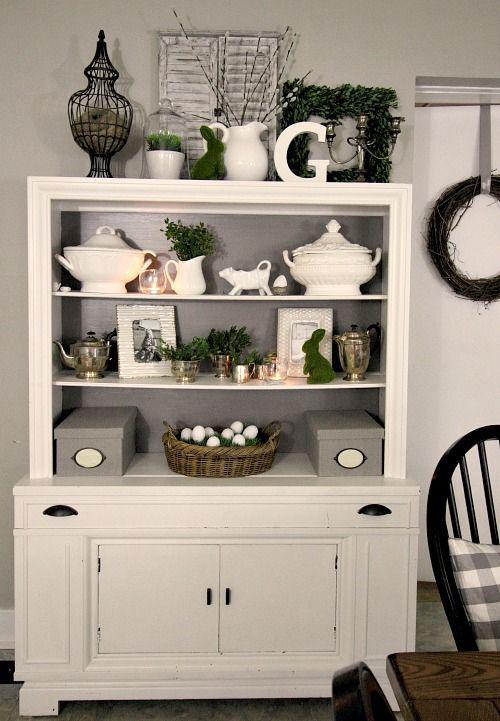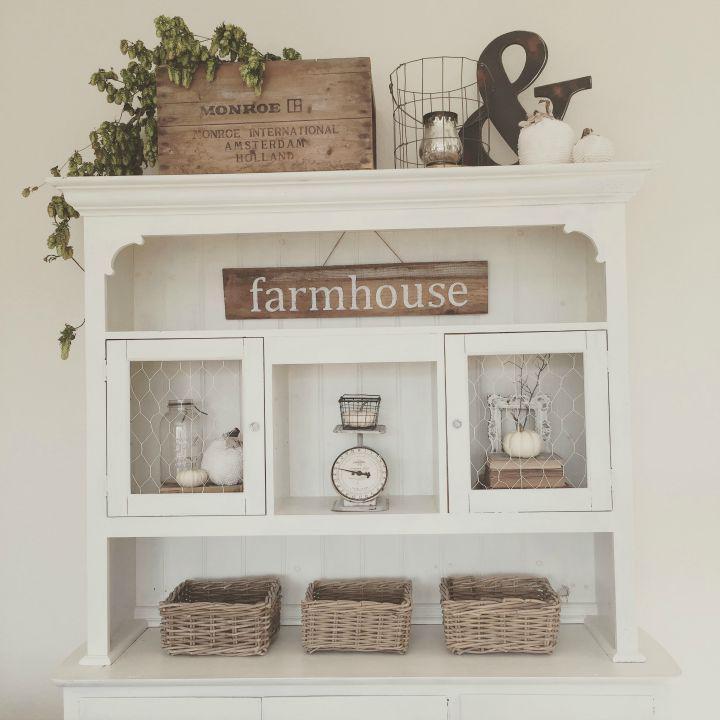The first image is the image on the left, the second image is the image on the right. For the images shown, is this caption "One of the cabinets is dark wood with four glass doors and a non-flat top." true? Answer yes or no. No. The first image is the image on the left, the second image is the image on the right. For the images shown, is this caption "There is a floor plant near a hutch in one of the images." true? Answer yes or no. No. 